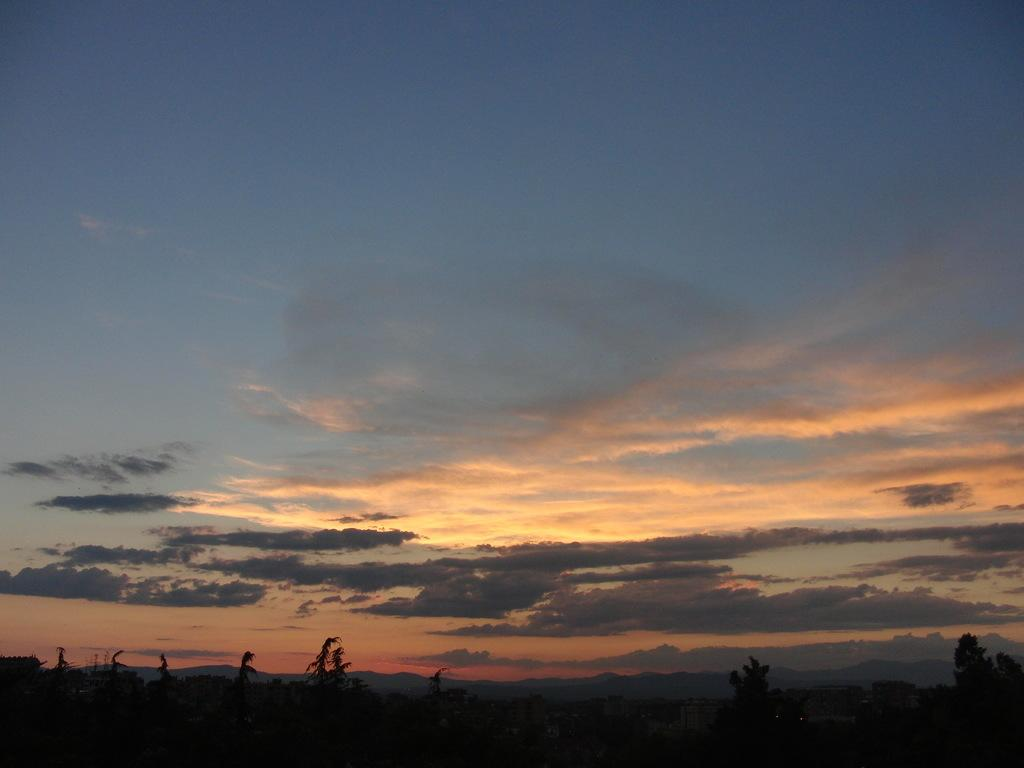What type of vegetation can be seen in the image? There are trees in the image. What can be seen in the sky in the image? There are clouds in the image. What type of boundary can be seen in the image? There is no boundary present in the image; it features trees and clouds. What type of calculator is visible in the image? There is no calculator present in the image. 